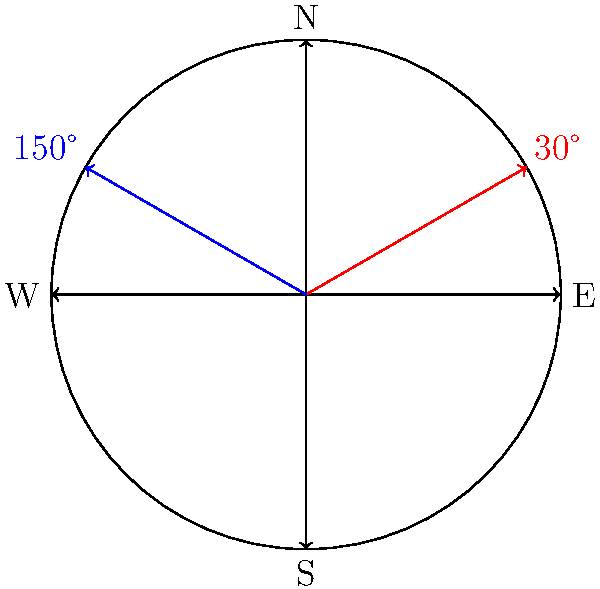During our expedition planning in Africa, we need to calculate the angle between two compass directions. The first direction is 30° east of north, and the second direction is 150° east of north. What is the smallest angle between these two directions? To find the smallest angle between the two directions, we can follow these steps:

1) First, visualize the compass directions on a circle, with north at 0° (or 360°), east at 90°, south at 180°, and west at 270°.

2) The first direction is 30° east of north, which is simply 30° on our compass.

3) The second direction is 150° east of north, which is 150° on our compass.

4) To find the angle between these directions, we subtract the smaller angle from the larger angle:

   $150° - 30° = 120°$

5) However, we need to check if this is the smallest angle. The smallest angle will always be less than or equal to 180°.

6) In this case, 120° is already less than 180°, so it is the smallest angle between the two directions.

Therefore, the smallest angle between the two compass directions is 120°.
Answer: 120° 